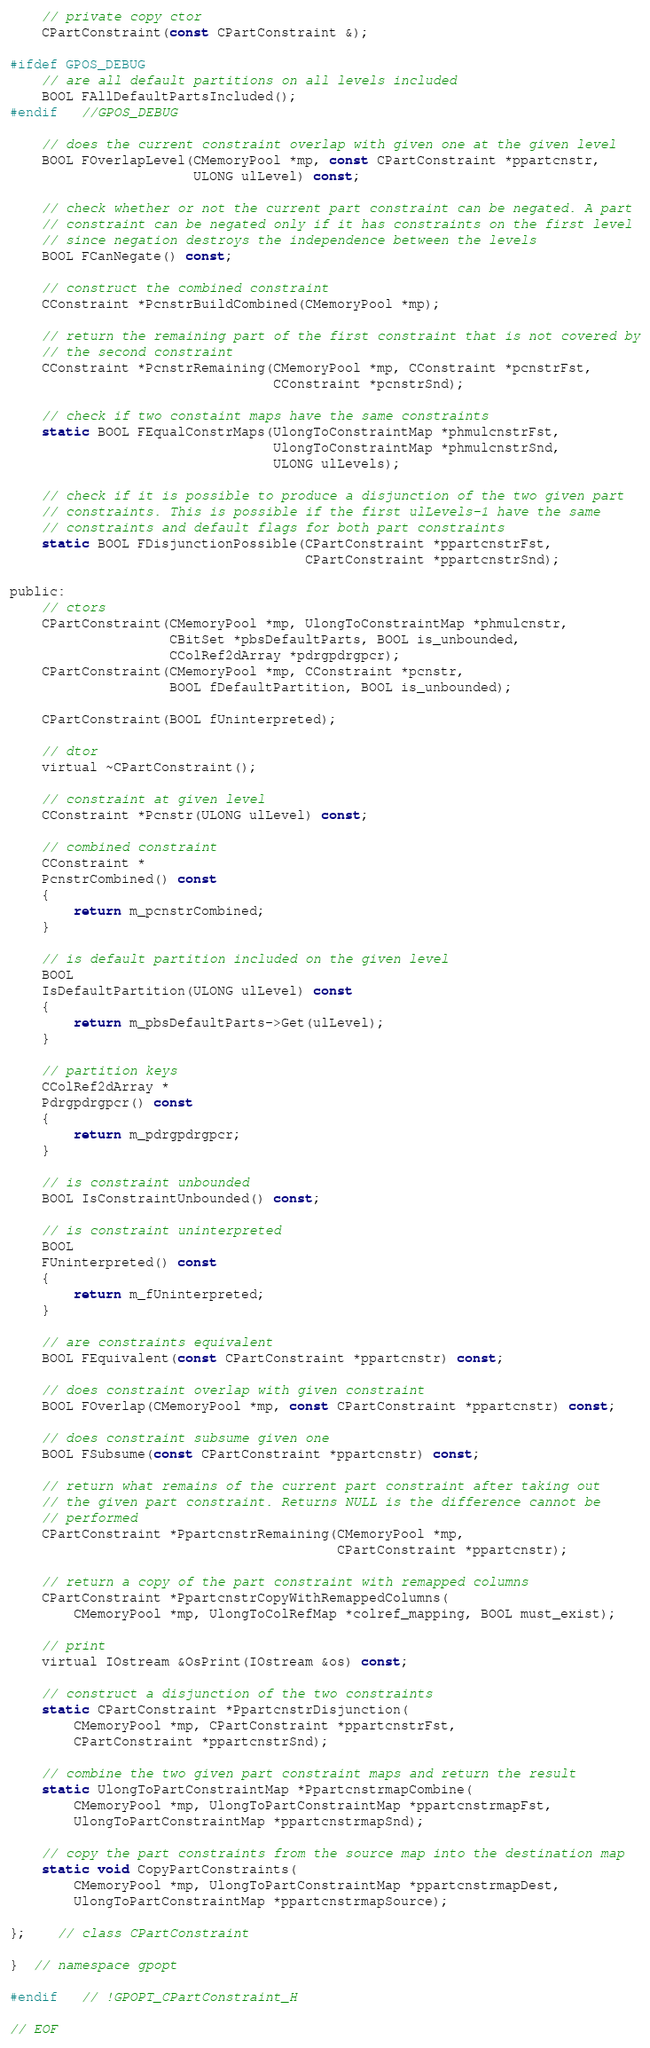<code> <loc_0><loc_0><loc_500><loc_500><_C_>
	// private copy ctor
	CPartConstraint(const CPartConstraint &);

#ifdef GPOS_DEBUG
	// are all default partitions on all levels included
	BOOL FAllDefaultPartsIncluded();
#endif	//GPOS_DEBUG

	// does the current constraint overlap with given one at the given level
	BOOL FOverlapLevel(CMemoryPool *mp, const CPartConstraint *ppartcnstr,
					   ULONG ulLevel) const;

	// check whether or not the current part constraint can be negated. A part
	// constraint can be negated only if it has constraints on the first level
	// since negation destroys the independence between the levels
	BOOL FCanNegate() const;

	// construct the combined constraint
	CConstraint *PcnstrBuildCombined(CMemoryPool *mp);

	// return the remaining part of the first constraint that is not covered by
	// the second constraint
	CConstraint *PcnstrRemaining(CMemoryPool *mp, CConstraint *pcnstrFst,
								 CConstraint *pcnstrSnd);

	// check if two constaint maps have the same constraints
	static BOOL FEqualConstrMaps(UlongToConstraintMap *phmulcnstrFst,
								 UlongToConstraintMap *phmulcnstrSnd,
								 ULONG ulLevels);

	// check if it is possible to produce a disjunction of the two given part
	// constraints. This is possible if the first ulLevels-1 have the same
	// constraints and default flags for both part constraints
	static BOOL FDisjunctionPossible(CPartConstraint *ppartcnstrFst,
									 CPartConstraint *ppartcnstrSnd);

public:
	// ctors
	CPartConstraint(CMemoryPool *mp, UlongToConstraintMap *phmulcnstr,
					CBitSet *pbsDefaultParts, BOOL is_unbounded,
					CColRef2dArray *pdrgpdrgpcr);
	CPartConstraint(CMemoryPool *mp, CConstraint *pcnstr,
					BOOL fDefaultPartition, BOOL is_unbounded);

	CPartConstraint(BOOL fUninterpreted);

	// dtor
	virtual ~CPartConstraint();

	// constraint at given level
	CConstraint *Pcnstr(ULONG ulLevel) const;

	// combined constraint
	CConstraint *
	PcnstrCombined() const
	{
		return m_pcnstrCombined;
	}

	// is default partition included on the given level
	BOOL
	IsDefaultPartition(ULONG ulLevel) const
	{
		return m_pbsDefaultParts->Get(ulLevel);
	}

	// partition keys
	CColRef2dArray *
	Pdrgpdrgpcr() const
	{
		return m_pdrgpdrgpcr;
	}

	// is constraint unbounded
	BOOL IsConstraintUnbounded() const;

	// is constraint uninterpreted
	BOOL
	FUninterpreted() const
	{
		return m_fUninterpreted;
	}

	// are constraints equivalent
	BOOL FEquivalent(const CPartConstraint *ppartcnstr) const;

	// does constraint overlap with given constraint
	BOOL FOverlap(CMemoryPool *mp, const CPartConstraint *ppartcnstr) const;

	// does constraint subsume given one
	BOOL FSubsume(const CPartConstraint *ppartcnstr) const;

	// return what remains of the current part constraint after taking out
	// the given part constraint. Returns NULL is the difference cannot be
	// performed
	CPartConstraint *PpartcnstrRemaining(CMemoryPool *mp,
										 CPartConstraint *ppartcnstr);

	// return a copy of the part constraint with remapped columns
	CPartConstraint *PpartcnstrCopyWithRemappedColumns(
		CMemoryPool *mp, UlongToColRefMap *colref_mapping, BOOL must_exist);

	// print
	virtual IOstream &OsPrint(IOstream &os) const;

	// construct a disjunction of the two constraints
	static CPartConstraint *PpartcnstrDisjunction(
		CMemoryPool *mp, CPartConstraint *ppartcnstrFst,
		CPartConstraint *ppartcnstrSnd);

	// combine the two given part constraint maps and return the result
	static UlongToPartConstraintMap *PpartcnstrmapCombine(
		CMemoryPool *mp, UlongToPartConstraintMap *ppartcnstrmapFst,
		UlongToPartConstraintMap *ppartcnstrmapSnd);

	// copy the part constraints from the source map into the destination map
	static void CopyPartConstraints(
		CMemoryPool *mp, UlongToPartConstraintMap *ppartcnstrmapDest,
		UlongToPartConstraintMap *ppartcnstrmapSource);

};	// class CPartConstraint

}  // namespace gpopt

#endif	// !GPOPT_CPartConstraint_H

// EOF
</code> 